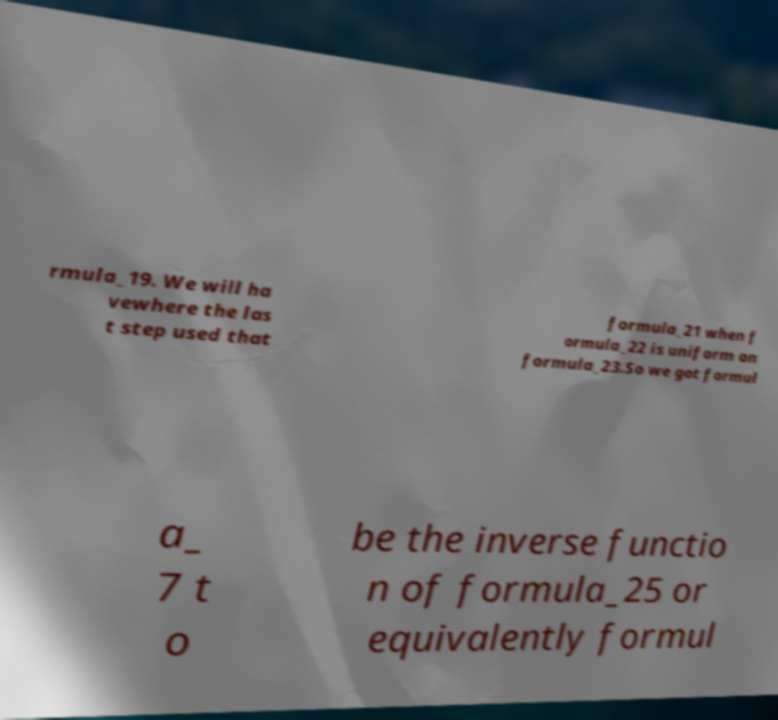I need the written content from this picture converted into text. Can you do that? rmula_19. We will ha vewhere the las t step used that formula_21 when f ormula_22 is uniform on formula_23.So we got formul a_ 7 t o be the inverse functio n of formula_25 or equivalently formul 